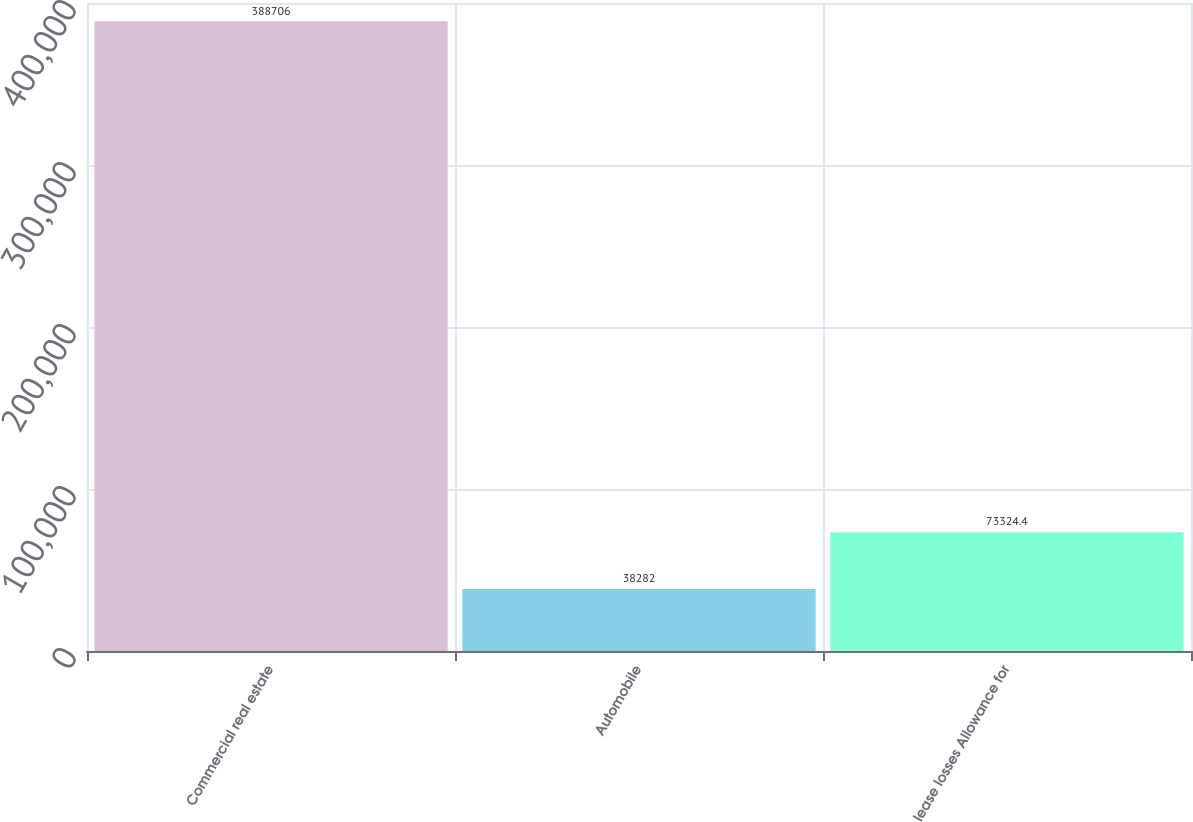Convert chart to OTSL. <chart><loc_0><loc_0><loc_500><loc_500><bar_chart><fcel>Commercial real estate<fcel>Automobile<fcel>lease losses Allowance for<nl><fcel>388706<fcel>38282<fcel>73324.4<nl></chart> 